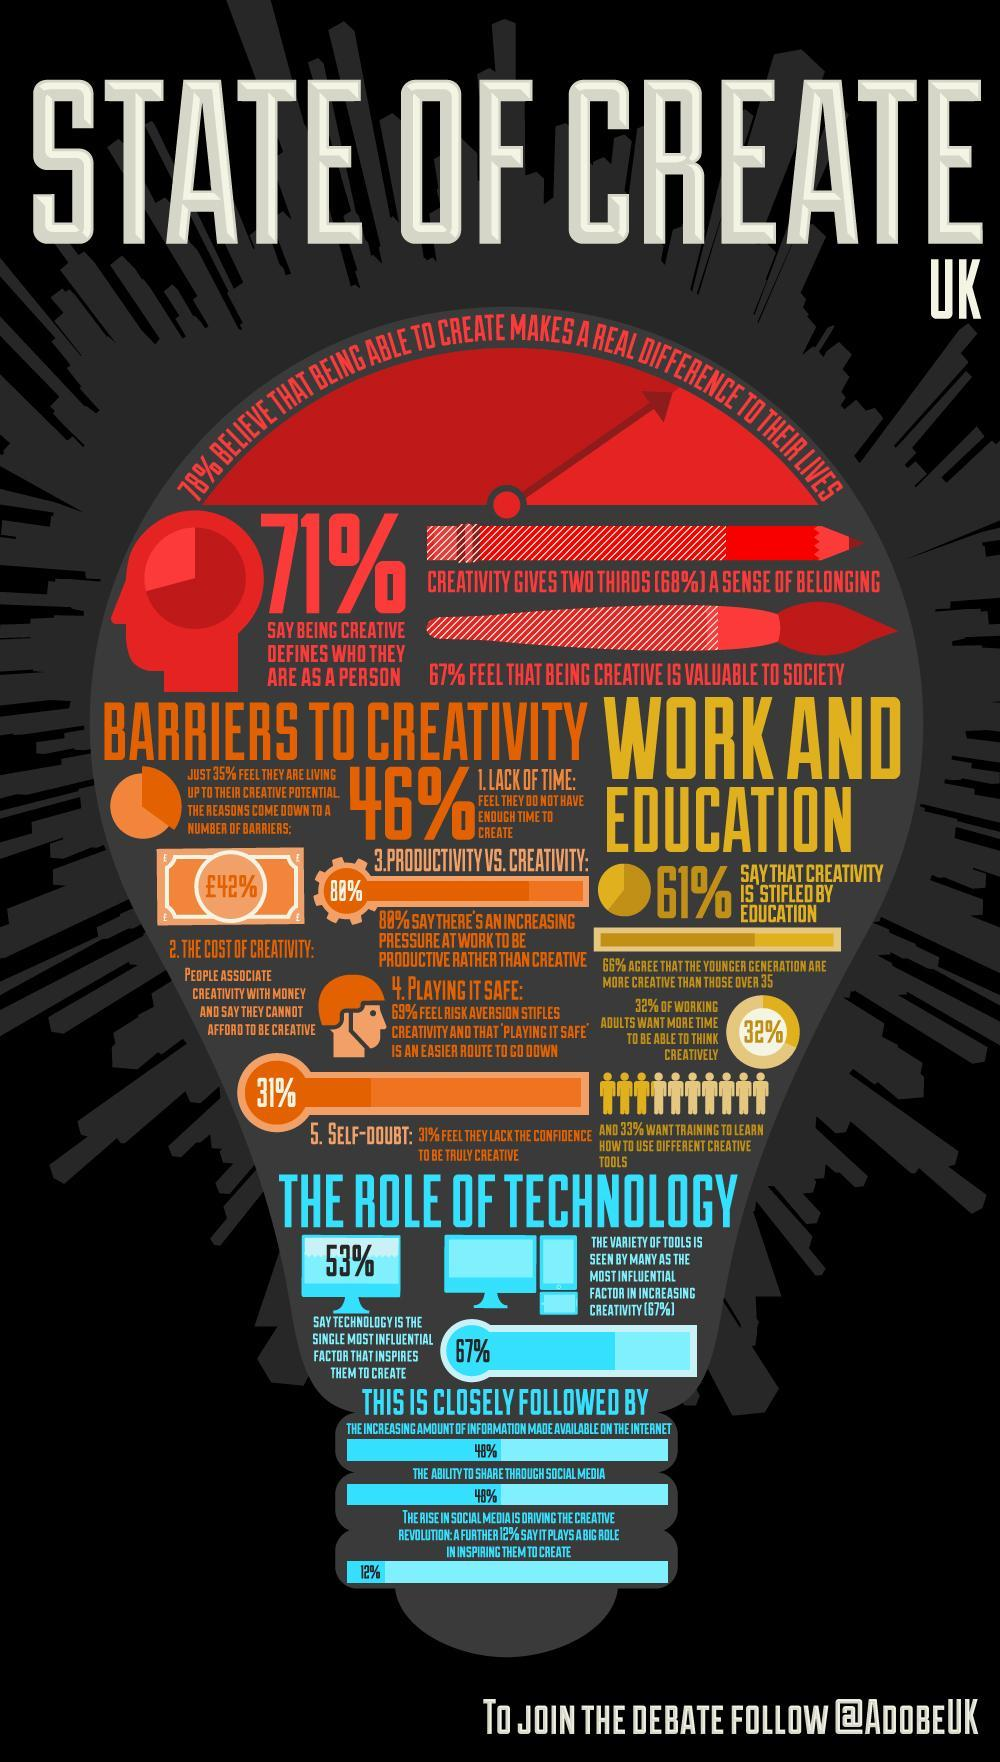What percentage of people in UK are not in self doubt as far as creativity is concerned?
Answer the question with a short phrase. 69% What percentage of people in UK have no enough time to be creative? 46% What percentage of people in UK do not think that creativity is stifled by education? 39% What percentage of UK people believe that being creative makes a real difference to their lives? 78% 